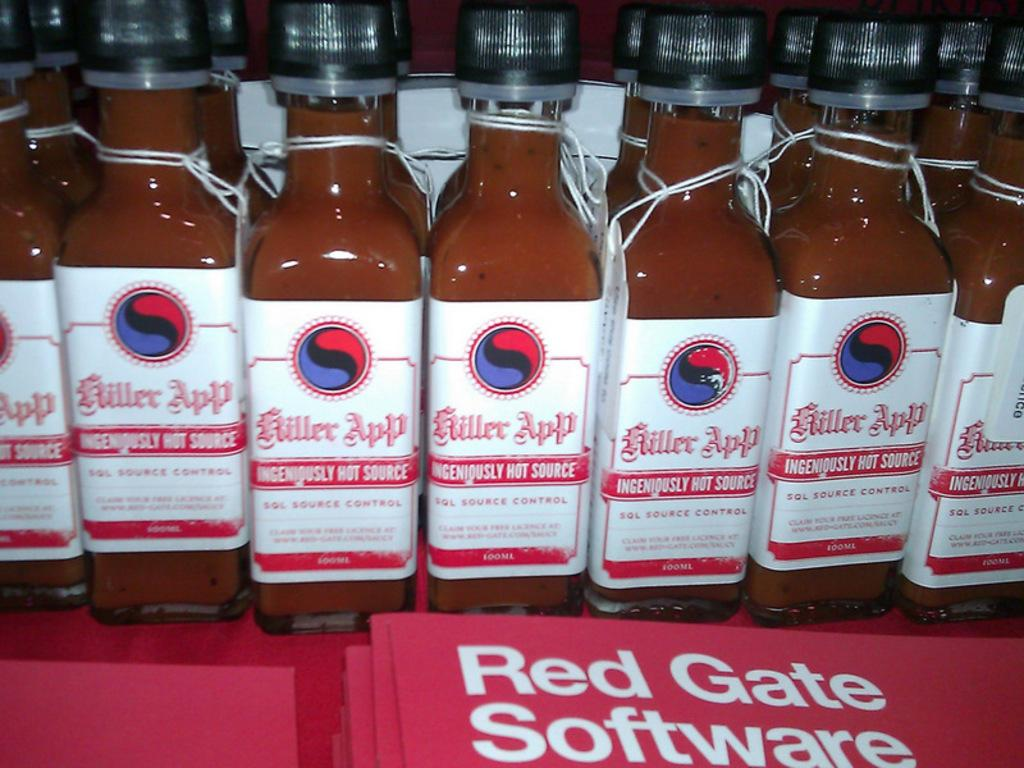<image>
Relay a brief, clear account of the picture shown. Fourteen 100 ml bottles of Killer App Ingeniously Hot Source on display. 